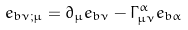Convert formula to latex. <formula><loc_0><loc_0><loc_500><loc_500>e _ { b \nu ; \mu } = \partial _ { \mu } e _ { b \nu } - \Gamma _ { \mu \nu } ^ { \alpha } e _ { b \alpha }</formula> 